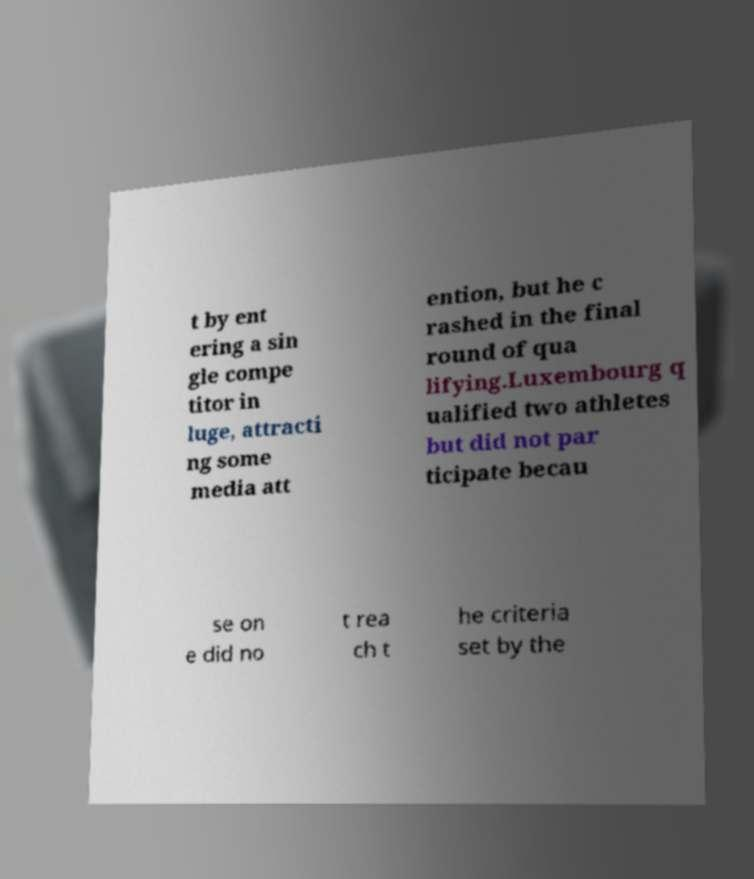Could you extract and type out the text from this image? t by ent ering a sin gle compe titor in luge, attracti ng some media att ention, but he c rashed in the final round of qua lifying.Luxembourg q ualified two athletes but did not par ticipate becau se on e did no t rea ch t he criteria set by the 